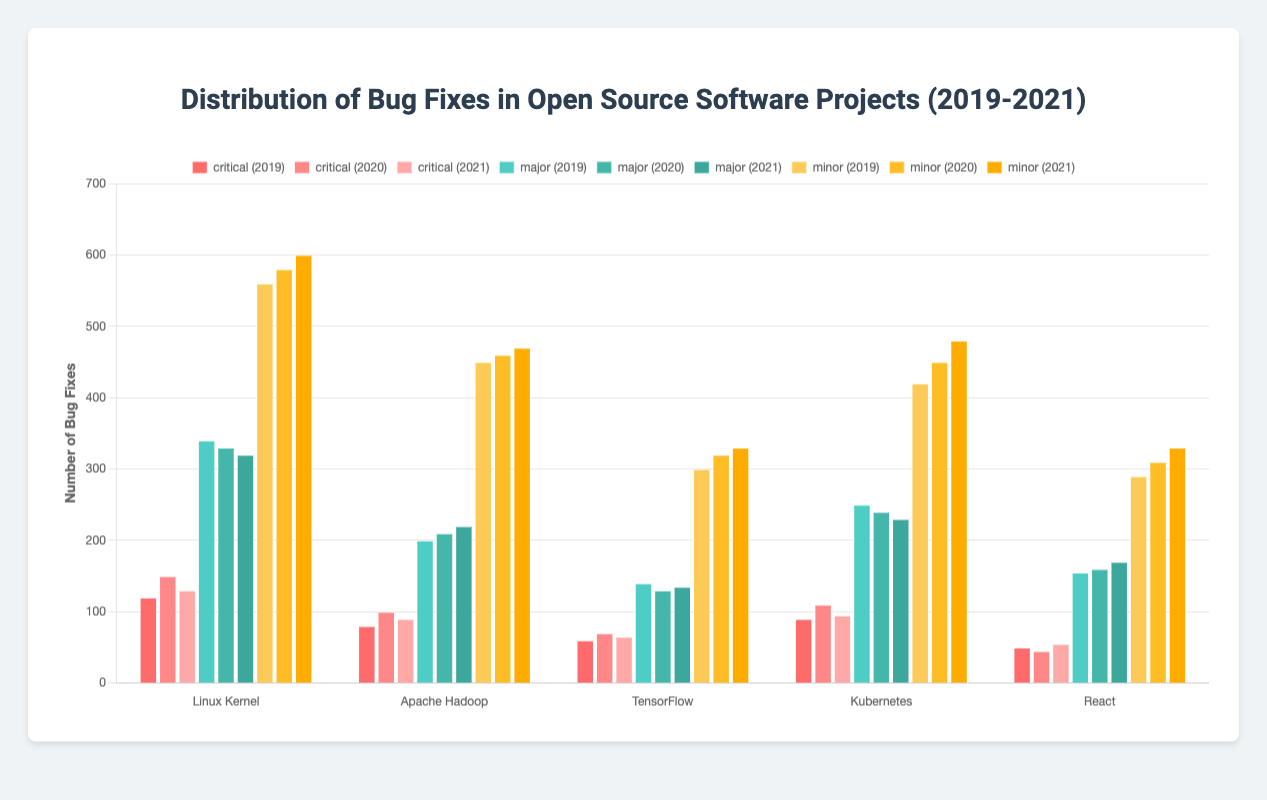How many total critical bug fixes were made in the Linux Kernel project over the years 2019 to 2021? The critical bug fixes in the Linux Kernel project over 2019, 2020, and 2021 are 120, 150, and 130 respectively. Summing these up: 120 + 150 + 130 = 400.
Answer: 400 Which project had the highest number of minor bug fixes in 2021? In 2021, the minor bug fixes for the projects are: Linux Kernel (600), Apache Hadoop (470), TensorFlow (330), Kubernetes (480), React (330). The highest value is 600, which is for the Linux Kernel.
Answer: Linux Kernel Compare the critical bug fixes in Kubernetes between 2019 and 2020. By how much did it increase? In Kubernetes, the critical bug fixes increased from 90 in 2019 to 110 in 2020. The difference is 110 - 90 = 20.
Answer: 20 Which severity of bugs (critical, major, minor) was fixed the most across all projects in 2020? Summing up the bug fixes across all projects in 2020 for each severity: Critical: 150 (Linux Kernel) + 100 (Apache Hadoop) + 70 (TensorFlow) + 110 (Kubernetes) + 45 (React) = 475. Major: 330 (Linux Kernel) + 210 (Apache Hadoop) + 130 (TensorFlow) + 240 (Kubernetes) + 160 (React) = 1070. Minor: 580 (Linux Kernel) + 460 (Apache Hadoop) + 320 (TensorFlow) + 450 (Kubernetes) + 310 (React) = 2120. The highest value is 2120 for minor bugs.
Answer: Minor What is the trend for major bug fixes in TensorFlow from 2019 to 2021? In TensorFlow, the major bug fixes over the years are: 2019 (140), 2020 (130), 2021 (135). From 2019 to 2020, there is a decrease (140 to 130), and from 2020 to 2021, there is a slight increase (130 to 135).
Answer: Decrease, then increase How does the average number of major bug fixes in Apache Hadoop from 2019 to 2021 compare to the average in React over the same period? Apache Hadoop major fixes: 2019 (200), 2020 (210), 2021 (220). Average: (200 + 210 + 220) / 3 = 210. React major fixes: 2019 (155), 2020 (160), 2021 (170). Average: (155 + 160 + 170) / 3 ≈ 161.67. Comparatively, Apache Hadoop's average (210) is higher than React's average (161.67).
Answer: Higher Which project had the least number of minor bug fixes in 2019? In 2019, the minor bug fixes for the projects are: Linux Kernel (560), Apache Hadoop (450), TensorFlow (300), Kubernetes (420), React (290). The least value is 290, which is for React.
Answer: React 